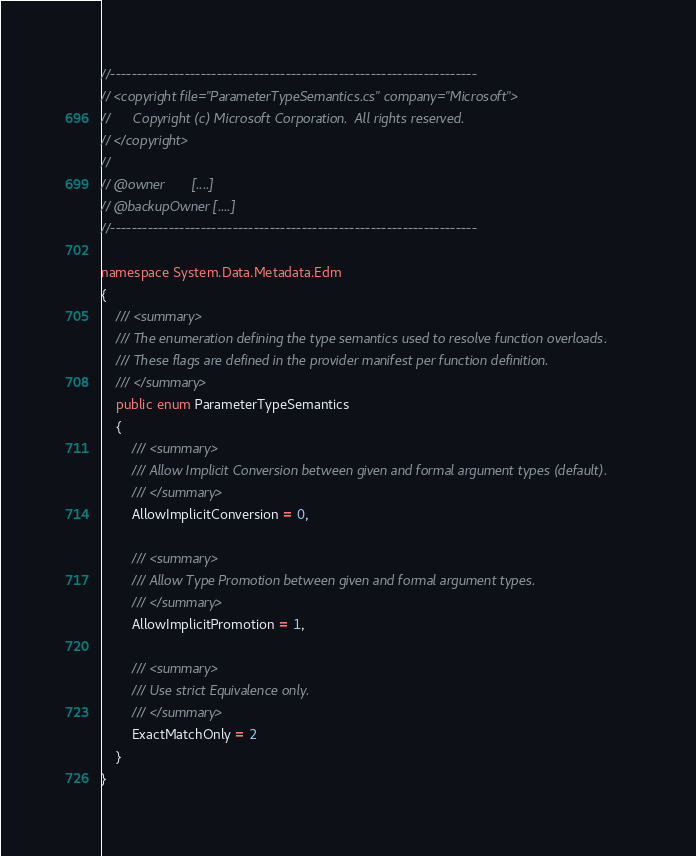Convert code to text. <code><loc_0><loc_0><loc_500><loc_500><_C#_>//---------------------------------------------------------------------
// <copyright file="ParameterTypeSemantics.cs" company="Microsoft">
//      Copyright (c) Microsoft Corporation.  All rights reserved.
// </copyright>
//
// @owner       [....]
// @backupOwner [....]
//---------------------------------------------------------------------

namespace System.Data.Metadata.Edm
{
    /// <summary>
    /// The enumeration defining the type semantics used to resolve function overloads. 
    /// These flags are defined in the provider manifest per function definition.
    /// </summary>
    public enum ParameterTypeSemantics
    {
        /// <summary>
        /// Allow Implicit Conversion between given and formal argument types (default).
        /// </summary>
        AllowImplicitConversion = 0,

        /// <summary>
        /// Allow Type Promotion between given and formal argument types.
        /// </summary>
        AllowImplicitPromotion = 1,

        /// <summary>
        /// Use strict Equivalence only.
        /// </summary>
        ExactMatchOnly = 2
    }
}
</code> 